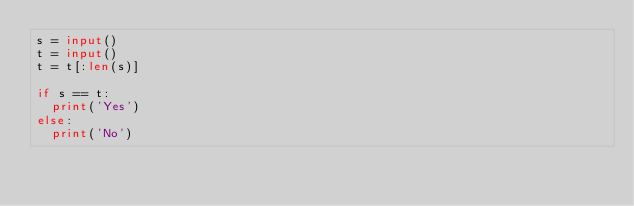<code> <loc_0><loc_0><loc_500><loc_500><_Python_>s = input()
t = input()
t = t[:len(s)]

if s == t:
  print('Yes')
else:
  print('No')
</code> 